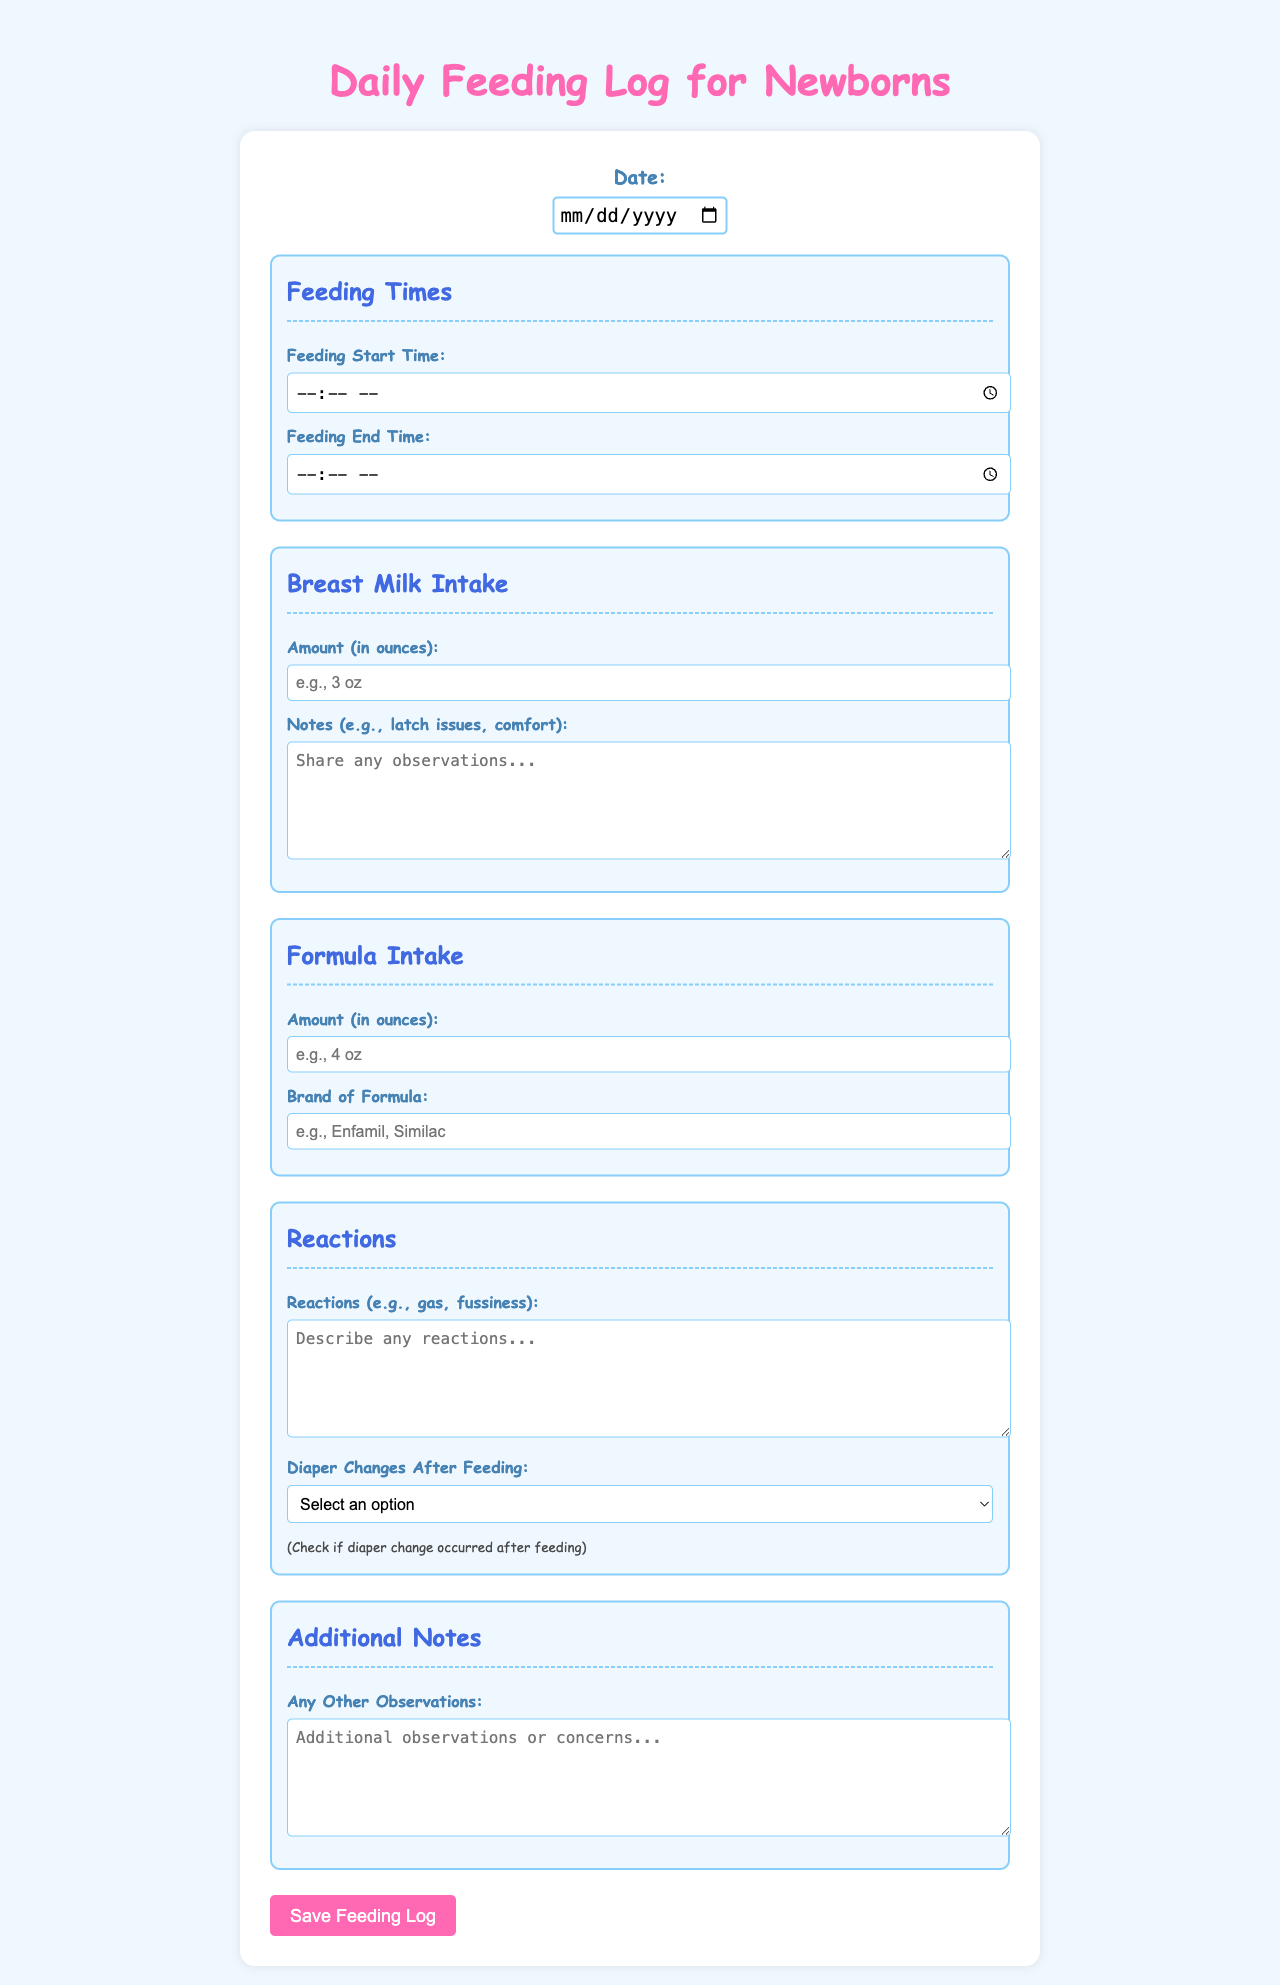What is the title of the document? The title of the document is stated prominently at the top of the form.
Answer: Daily Feeding Log for Newborns What are the colors used for the headings? The colors of the headings can give insight into design choices in the document. The main heading is pink and the section headings are blue.
Answer: Pink and blue What input is required for the feeding start time? The feeding start time field has a specific format required for input as indicated in the document.
Answer: Time What should be noted under Breast Milk Intake? The section specifies the information that needs to be filled in for the breast milk intake.
Answer: Amount and notes How is additional information for reactions captured? The document provides a section specifically for capturing any reactions post-feeding, indicating multiple observations may be recorded.
Answer: Reactions and diaper change What is the purpose of the Additional Notes section? The additional notes allows caregivers to capture insights or concerns that may not fit into other categories.
Answer: Observations or concerns Are diaper changes recorded in this document? The document includes a field to record if diaper changes occurred after feeding, showing it's an important point of tracking.
Answer: Yes What type of system is the document designed for? The structure and fields suggest it is specifically tailored for tracking feeding details of infants or newborns.
Answer: Newborn feeding log What style of font is used in the document? The document specifies a casual font style meant for readability and relatability.
Answer: Comic Sans MS 